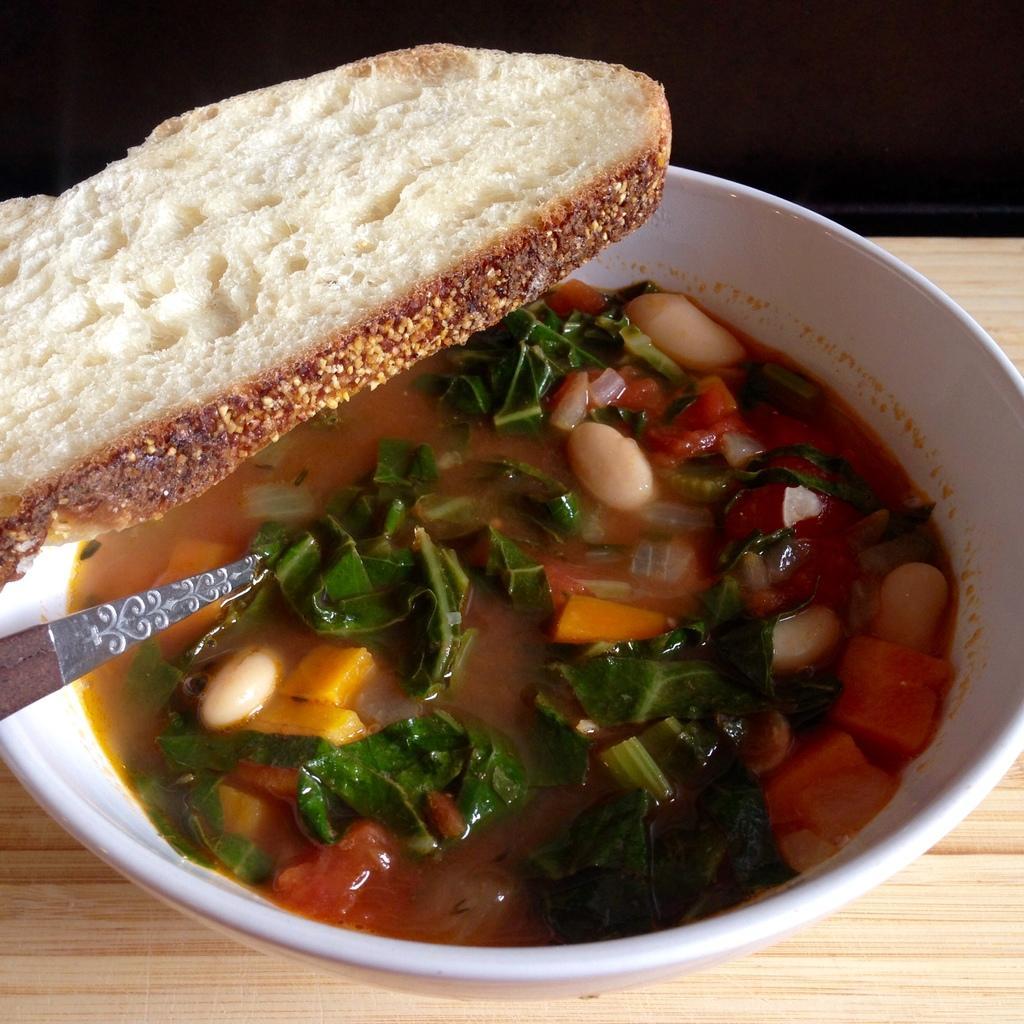How would you summarize this image in a sentence or two? In the picture we can see a bowl with a curry with a spoon in it and it is placed on the wooden plank and on the top of the bowl we can see the slice of the bread. 